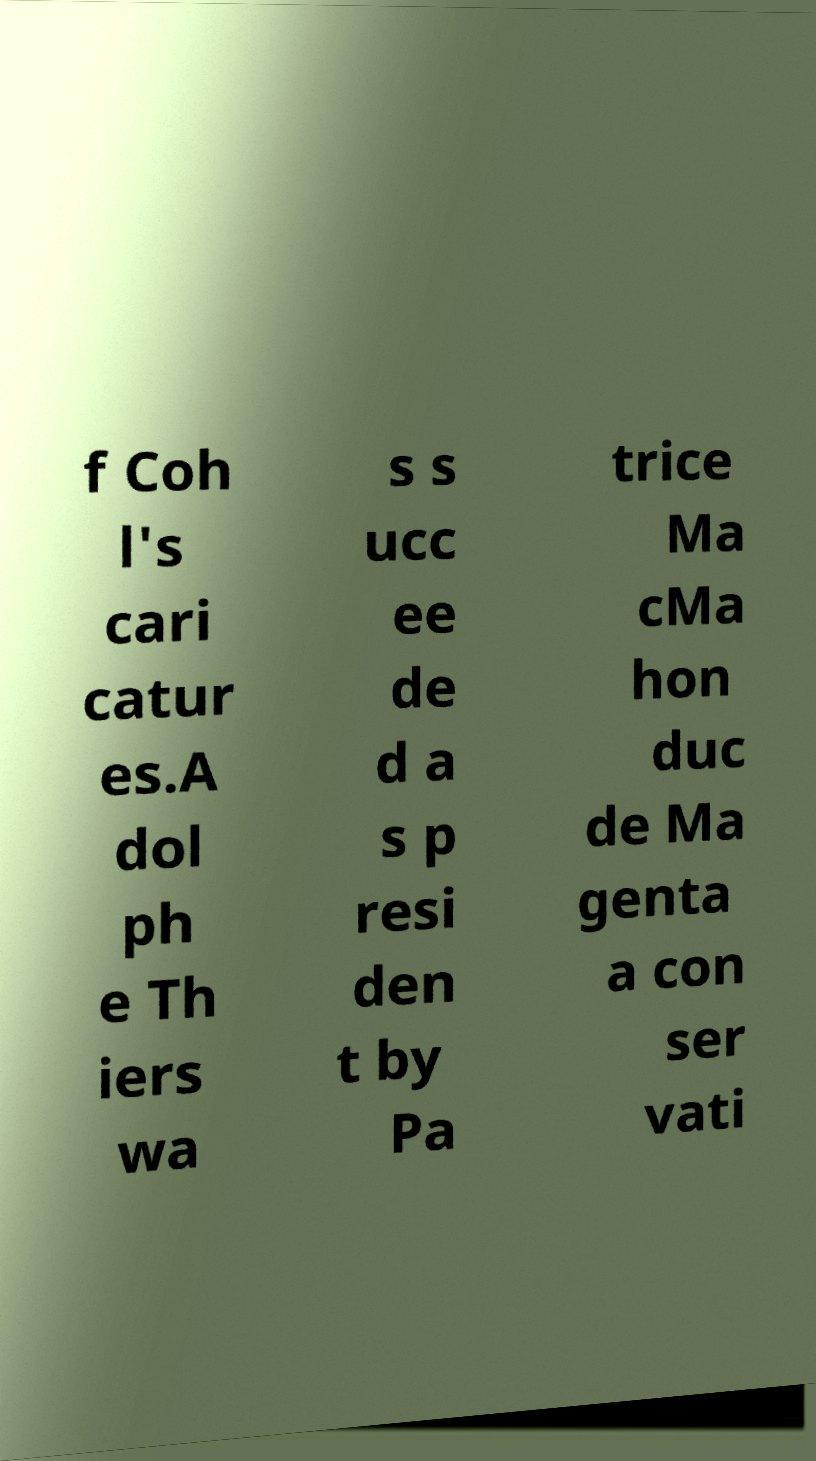I need the written content from this picture converted into text. Can you do that? f Coh l's cari catur es.A dol ph e Th iers wa s s ucc ee de d a s p resi den t by Pa trice Ma cMa hon duc de Ma genta a con ser vati 